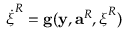Convert formula to latex. <formula><loc_0><loc_0><loc_500><loc_500>\dot { \xi } ^ { R } = g ( y , a ^ { R } , { \xi } ^ { R } )</formula> 